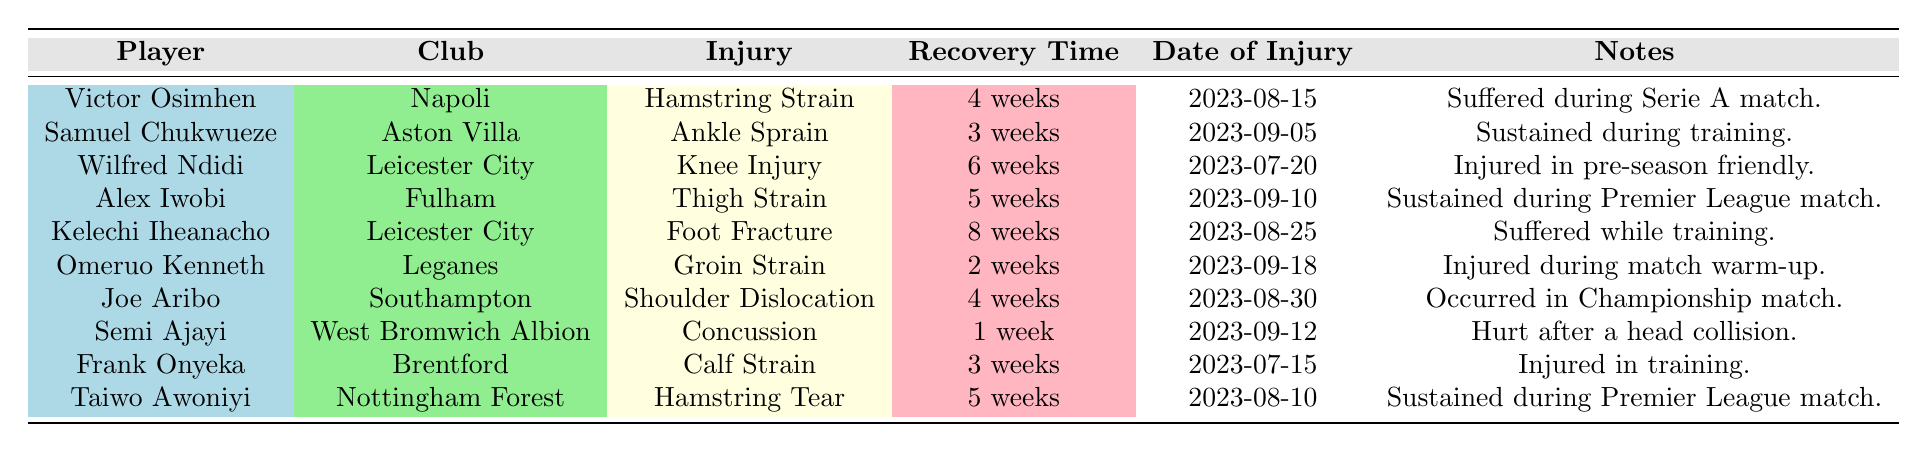What injury did Victor Osimhen sustain? The table indicates that Victor Osimhen sustained a hamstring strain, as stated in the "Injury" column corresponding to his name.
Answer: Hamstring Strain How many weeks is Kelechi Iheanacho expected to be out due to his injury? Referring to the recovery time listed for Kelechi Iheanacho in the table, it shows that he is expected to be out for 8 weeks.
Answer: 8 weeks Did any player suffer an injury during training? The table presents several players and notes about their injuries. It mentions that both Samuel Chukwueze and Frank Onyeka sustained injuries during training, confirming that there are players who suffered injuries in this manner.
Answer: Yes Which player has the longest recovery time and what is it? By examining the recovery times for all players, Kelechi Iheanacho is found to have the longest recovery period of 8 weeks, noted in the recovery time column.
Answer: Kelechi Iheanacho, 8 weeks What is the total recovery time of players from Leicester City? The recovery times for Leicester City players Wilfred Ndidi (6 weeks) and Kelechi Iheanacho (8 weeks) total up to 14 weeks (6 + 8). Thus, the total recovery time for players from that club is 14 weeks.
Answer: 14 weeks Is Joe Aribo's dislocated shoulder the only injury listed from Southampton? The table shows that Joe Aribo suffered a shoulder dislocation while playing for Southampton, and there are no other players listed from Southampton, confirming that he is the only one.
Answer: Yes Which injuries resulted from matches? Reviewing the table, the injuries sustained during matches include: Victor Osimhen (hamstring strain), Alex Iwobi (thigh strain), Taiwo Awoniyi (hamstring tear), and Joe Aribo (shoulder dislocation). This indicates multiple injuries occurred during matches.
Answer: 4 injuries How many players are expected to return within 3 weeks or less? From the recovery times in the table, Omeruo Kenneth (2 weeks) and Semi Ajayi (1 week) are both expected to return in 3 weeks or less. Therefore, there are a total of 2 players who fit this criteria.
Answer: 2 players 